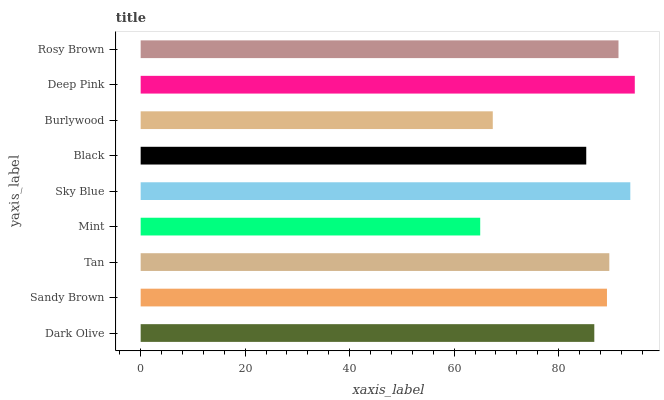Is Mint the minimum?
Answer yes or no. Yes. Is Deep Pink the maximum?
Answer yes or no. Yes. Is Sandy Brown the minimum?
Answer yes or no. No. Is Sandy Brown the maximum?
Answer yes or no. No. Is Sandy Brown greater than Dark Olive?
Answer yes or no. Yes. Is Dark Olive less than Sandy Brown?
Answer yes or no. Yes. Is Dark Olive greater than Sandy Brown?
Answer yes or no. No. Is Sandy Brown less than Dark Olive?
Answer yes or no. No. Is Sandy Brown the high median?
Answer yes or no. Yes. Is Sandy Brown the low median?
Answer yes or no. Yes. Is Sky Blue the high median?
Answer yes or no. No. Is Black the low median?
Answer yes or no. No. 